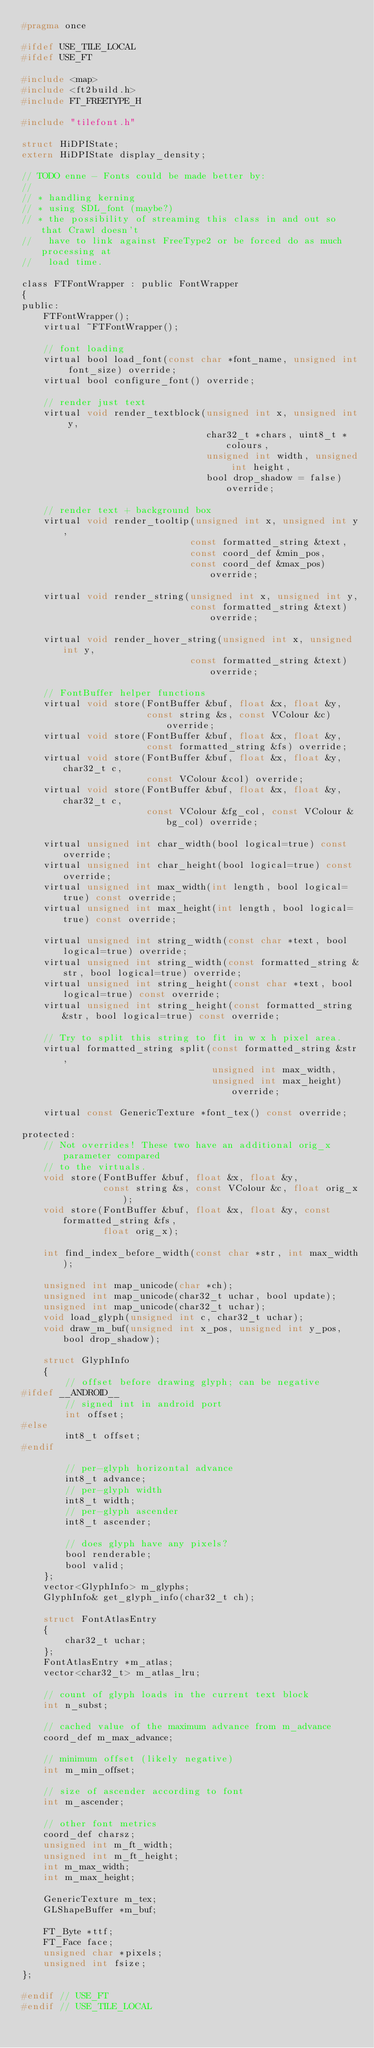Convert code to text. <code><loc_0><loc_0><loc_500><loc_500><_C_>#pragma once

#ifdef USE_TILE_LOCAL
#ifdef USE_FT

#include <map>
#include <ft2build.h>
#include FT_FREETYPE_H

#include "tilefont.h"

struct HiDPIState;
extern HiDPIState display_density;

// TODO enne - Fonts could be made better by:
//
// * handling kerning
// * using SDL_font (maybe?)
// * the possibility of streaming this class in and out so that Crawl doesn't
//   have to link against FreeType2 or be forced do as much processing at
//   load time.

class FTFontWrapper : public FontWrapper
{
public:
    FTFontWrapper();
    virtual ~FTFontWrapper();

    // font loading
    virtual bool load_font(const char *font_name, unsigned int font_size) override;
    virtual bool configure_font() override;

    // render just text
    virtual void render_textblock(unsigned int x, unsigned int y,
                                  char32_t *chars, uint8_t *colours,
                                  unsigned int width, unsigned int height,
                                  bool drop_shadow = false) override;

    // render text + background box
    virtual void render_tooltip(unsigned int x, unsigned int y,
                               const formatted_string &text,
                               const coord_def &min_pos,
                               const coord_def &max_pos) override;

    virtual void render_string(unsigned int x, unsigned int y,
                               const formatted_string &text) override;

    virtual void render_hover_string(unsigned int x, unsigned int y,
                               const formatted_string &text) override;

    // FontBuffer helper functions
    virtual void store(FontBuffer &buf, float &x, float &y,
                       const string &s, const VColour &c) override;
    virtual void store(FontBuffer &buf, float &x, float &y,
                       const formatted_string &fs) override;
    virtual void store(FontBuffer &buf, float &x, float &y, char32_t c,
                       const VColour &col) override;
    virtual void store(FontBuffer &buf, float &x, float &y, char32_t c,
                       const VColour &fg_col, const VColour &bg_col) override;

    virtual unsigned int char_width(bool logical=true) const override;
    virtual unsigned int char_height(bool logical=true) const override;
    virtual unsigned int max_width(int length, bool logical=true) const override;
    virtual unsigned int max_height(int length, bool logical=true) const override;

    virtual unsigned int string_width(const char *text, bool logical=true) override;
    virtual unsigned int string_width(const formatted_string &str, bool logical=true) override;
    virtual unsigned int string_height(const char *text, bool logical=true) const override;
    virtual unsigned int string_height(const formatted_string &str, bool logical=true) const override;

    // Try to split this string to fit in w x h pixel area.
    virtual formatted_string split(const formatted_string &str,
                                   unsigned int max_width,
                                   unsigned int max_height) override;

    virtual const GenericTexture *font_tex() const override;

protected:
    // Not overrides! These two have an additional orig_x parameter compared
    // to the virtuals.
    void store(FontBuffer &buf, float &x, float &y,
               const string &s, const VColour &c, float orig_x);
    void store(FontBuffer &buf, float &x, float &y, const formatted_string &fs,
               float orig_x);

    int find_index_before_width(const char *str, int max_width);

    unsigned int map_unicode(char *ch);
    unsigned int map_unicode(char32_t uchar, bool update);
    unsigned int map_unicode(char32_t uchar);
    void load_glyph(unsigned int c, char32_t uchar);
    void draw_m_buf(unsigned int x_pos, unsigned int y_pos, bool drop_shadow);

    struct GlyphInfo
    {
        // offset before drawing glyph; can be negative
#ifdef __ANDROID__
        // signed int in android port
        int offset;
#else
        int8_t offset;
#endif

        // per-glyph horizontal advance
        int8_t advance;
        // per-glyph width
        int8_t width;
        // per-glyph ascender
        int8_t ascender;

        // does glyph have any pixels?
        bool renderable;
        bool valid;
    };
    vector<GlyphInfo> m_glyphs;
    GlyphInfo& get_glyph_info(char32_t ch);

    struct FontAtlasEntry
    {
        char32_t uchar;
    };
    FontAtlasEntry *m_atlas;
    vector<char32_t> m_atlas_lru;

    // count of glyph loads in the current text block
    int n_subst;

    // cached value of the maximum advance from m_advance
    coord_def m_max_advance;

    // minimum offset (likely negative)
    int m_min_offset;

    // size of ascender according to font
    int m_ascender;

    // other font metrics
    coord_def charsz;
    unsigned int m_ft_width;
    unsigned int m_ft_height;
    int m_max_width;
    int m_max_height;

    GenericTexture m_tex;
    GLShapeBuffer *m_buf;

    FT_Byte *ttf;
    FT_Face face;
    unsigned char *pixels;
    unsigned int fsize;
};

#endif // USE_FT
#endif // USE_TILE_LOCAL
</code> 